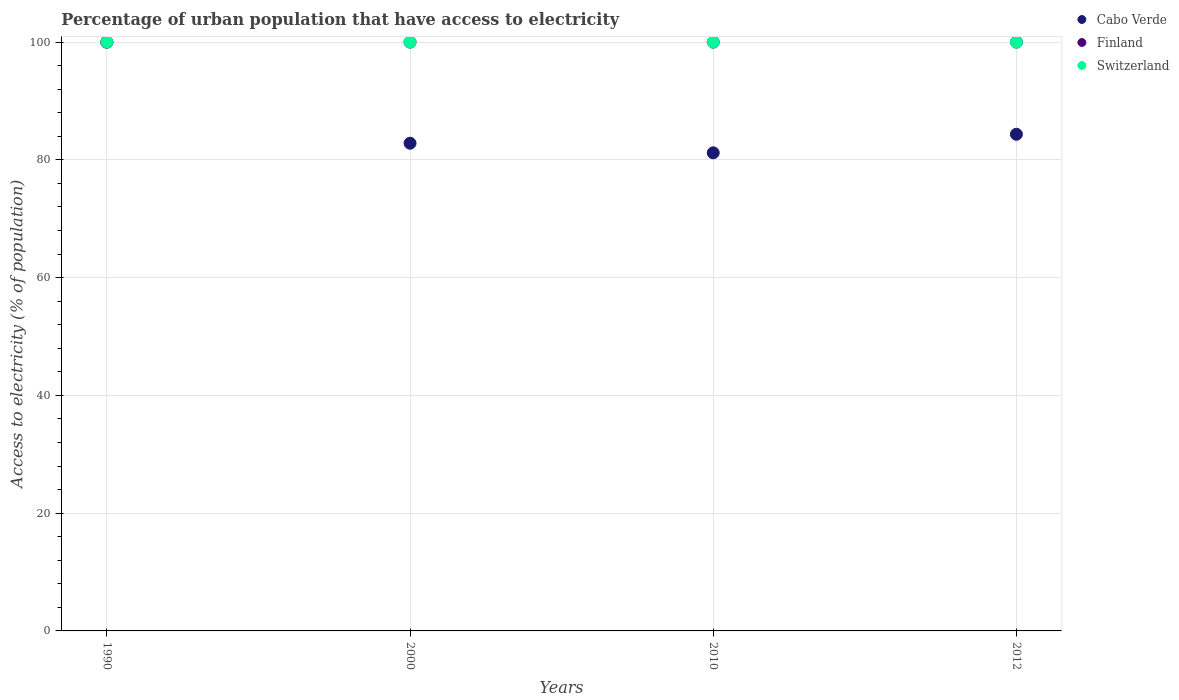Is the number of dotlines equal to the number of legend labels?
Offer a very short reply. Yes. What is the percentage of urban population that have access to electricity in Switzerland in 2012?
Provide a succinct answer. 100. Across all years, what is the maximum percentage of urban population that have access to electricity in Switzerland?
Provide a short and direct response. 100. Across all years, what is the minimum percentage of urban population that have access to electricity in Switzerland?
Your response must be concise. 100. In which year was the percentage of urban population that have access to electricity in Cabo Verde maximum?
Your answer should be compact. 1990. What is the total percentage of urban population that have access to electricity in Cabo Verde in the graph?
Give a very brief answer. 348.37. What is the difference between the percentage of urban population that have access to electricity in Cabo Verde in 2000 and that in 2012?
Make the answer very short. -1.53. What is the difference between the percentage of urban population that have access to electricity in Cabo Verde in 1990 and the percentage of urban population that have access to electricity in Finland in 2012?
Offer a very short reply. 0. In the year 2000, what is the difference between the percentage of urban population that have access to electricity in Switzerland and percentage of urban population that have access to electricity in Cabo Verde?
Your response must be concise. 17.17. In how many years, is the percentage of urban population that have access to electricity in Cabo Verde greater than 4 %?
Your answer should be very brief. 4. What is the difference between the highest and the lowest percentage of urban population that have access to electricity in Cabo Verde?
Your answer should be very brief. 18.8. In how many years, is the percentage of urban population that have access to electricity in Cabo Verde greater than the average percentage of urban population that have access to electricity in Cabo Verde taken over all years?
Your response must be concise. 1. Is the sum of the percentage of urban population that have access to electricity in Cabo Verde in 2000 and 2010 greater than the maximum percentage of urban population that have access to electricity in Switzerland across all years?
Your response must be concise. Yes. Is it the case that in every year, the sum of the percentage of urban population that have access to electricity in Finland and percentage of urban population that have access to electricity in Cabo Verde  is greater than the percentage of urban population that have access to electricity in Switzerland?
Provide a succinct answer. Yes. Does the percentage of urban population that have access to electricity in Finland monotonically increase over the years?
Your answer should be compact. No. Is the percentage of urban population that have access to electricity in Finland strictly less than the percentage of urban population that have access to electricity in Cabo Verde over the years?
Your answer should be very brief. No. How many dotlines are there?
Your answer should be very brief. 3. How many years are there in the graph?
Your answer should be very brief. 4. What is the difference between two consecutive major ticks on the Y-axis?
Make the answer very short. 20. Are the values on the major ticks of Y-axis written in scientific E-notation?
Your answer should be compact. No. Does the graph contain grids?
Your response must be concise. Yes. How many legend labels are there?
Ensure brevity in your answer.  3. How are the legend labels stacked?
Provide a short and direct response. Vertical. What is the title of the graph?
Provide a short and direct response. Percentage of urban population that have access to electricity. Does "Bahamas" appear as one of the legend labels in the graph?
Give a very brief answer. No. What is the label or title of the X-axis?
Ensure brevity in your answer.  Years. What is the label or title of the Y-axis?
Your answer should be compact. Access to electricity (% of population). What is the Access to electricity (% of population) of Cabo Verde in 1990?
Provide a succinct answer. 100. What is the Access to electricity (% of population) of Switzerland in 1990?
Offer a terse response. 100. What is the Access to electricity (% of population) in Cabo Verde in 2000?
Provide a succinct answer. 82.83. What is the Access to electricity (% of population) of Cabo Verde in 2010?
Your answer should be very brief. 81.2. What is the Access to electricity (% of population) of Cabo Verde in 2012?
Keep it short and to the point. 84.35. Across all years, what is the maximum Access to electricity (% of population) in Finland?
Provide a succinct answer. 100. Across all years, what is the maximum Access to electricity (% of population) of Switzerland?
Provide a succinct answer. 100. Across all years, what is the minimum Access to electricity (% of population) of Cabo Verde?
Keep it short and to the point. 81.2. Across all years, what is the minimum Access to electricity (% of population) of Switzerland?
Provide a short and direct response. 100. What is the total Access to electricity (% of population) in Cabo Verde in the graph?
Your answer should be compact. 348.37. What is the total Access to electricity (% of population) in Switzerland in the graph?
Provide a succinct answer. 400. What is the difference between the Access to electricity (% of population) in Cabo Verde in 1990 and that in 2000?
Make the answer very short. 17.17. What is the difference between the Access to electricity (% of population) in Finland in 1990 and that in 2000?
Offer a terse response. 0. What is the difference between the Access to electricity (% of population) in Switzerland in 1990 and that in 2000?
Offer a terse response. 0. What is the difference between the Access to electricity (% of population) of Cabo Verde in 1990 and that in 2010?
Ensure brevity in your answer.  18.8. What is the difference between the Access to electricity (% of population) in Finland in 1990 and that in 2010?
Make the answer very short. 0. What is the difference between the Access to electricity (% of population) of Cabo Verde in 1990 and that in 2012?
Your answer should be compact. 15.65. What is the difference between the Access to electricity (% of population) in Switzerland in 1990 and that in 2012?
Provide a succinct answer. 0. What is the difference between the Access to electricity (% of population) of Cabo Verde in 2000 and that in 2010?
Offer a very short reply. 1.63. What is the difference between the Access to electricity (% of population) in Finland in 2000 and that in 2010?
Give a very brief answer. 0. What is the difference between the Access to electricity (% of population) of Switzerland in 2000 and that in 2010?
Make the answer very short. 0. What is the difference between the Access to electricity (% of population) of Cabo Verde in 2000 and that in 2012?
Give a very brief answer. -1.53. What is the difference between the Access to electricity (% of population) of Cabo Verde in 2010 and that in 2012?
Offer a terse response. -3.15. What is the difference between the Access to electricity (% of population) of Finland in 2010 and that in 2012?
Your answer should be very brief. 0. What is the difference between the Access to electricity (% of population) of Cabo Verde in 1990 and the Access to electricity (% of population) of Switzerland in 2000?
Your response must be concise. 0. What is the difference between the Access to electricity (% of population) in Finland in 1990 and the Access to electricity (% of population) in Switzerland in 2000?
Your answer should be very brief. 0. What is the difference between the Access to electricity (% of population) of Cabo Verde in 1990 and the Access to electricity (% of population) of Finland in 2010?
Provide a succinct answer. 0. What is the difference between the Access to electricity (% of population) in Cabo Verde in 1990 and the Access to electricity (% of population) in Switzerland in 2010?
Offer a very short reply. 0. What is the difference between the Access to electricity (% of population) of Cabo Verde in 1990 and the Access to electricity (% of population) of Finland in 2012?
Your response must be concise. 0. What is the difference between the Access to electricity (% of population) of Finland in 1990 and the Access to electricity (% of population) of Switzerland in 2012?
Your answer should be compact. 0. What is the difference between the Access to electricity (% of population) of Cabo Verde in 2000 and the Access to electricity (% of population) of Finland in 2010?
Your answer should be very brief. -17.17. What is the difference between the Access to electricity (% of population) in Cabo Verde in 2000 and the Access to electricity (% of population) in Switzerland in 2010?
Provide a short and direct response. -17.17. What is the difference between the Access to electricity (% of population) of Finland in 2000 and the Access to electricity (% of population) of Switzerland in 2010?
Make the answer very short. 0. What is the difference between the Access to electricity (% of population) in Cabo Verde in 2000 and the Access to electricity (% of population) in Finland in 2012?
Give a very brief answer. -17.17. What is the difference between the Access to electricity (% of population) in Cabo Verde in 2000 and the Access to electricity (% of population) in Switzerland in 2012?
Provide a short and direct response. -17.17. What is the difference between the Access to electricity (% of population) in Finland in 2000 and the Access to electricity (% of population) in Switzerland in 2012?
Offer a terse response. 0. What is the difference between the Access to electricity (% of population) in Cabo Verde in 2010 and the Access to electricity (% of population) in Finland in 2012?
Keep it short and to the point. -18.8. What is the difference between the Access to electricity (% of population) of Cabo Verde in 2010 and the Access to electricity (% of population) of Switzerland in 2012?
Your answer should be very brief. -18.8. What is the average Access to electricity (% of population) in Cabo Verde per year?
Give a very brief answer. 87.09. What is the average Access to electricity (% of population) in Switzerland per year?
Provide a succinct answer. 100. In the year 1990, what is the difference between the Access to electricity (% of population) in Cabo Verde and Access to electricity (% of population) in Finland?
Keep it short and to the point. 0. In the year 1990, what is the difference between the Access to electricity (% of population) of Cabo Verde and Access to electricity (% of population) of Switzerland?
Provide a short and direct response. 0. In the year 2000, what is the difference between the Access to electricity (% of population) in Cabo Verde and Access to electricity (% of population) in Finland?
Give a very brief answer. -17.17. In the year 2000, what is the difference between the Access to electricity (% of population) in Cabo Verde and Access to electricity (% of population) in Switzerland?
Offer a very short reply. -17.17. In the year 2000, what is the difference between the Access to electricity (% of population) in Finland and Access to electricity (% of population) in Switzerland?
Make the answer very short. 0. In the year 2010, what is the difference between the Access to electricity (% of population) in Cabo Verde and Access to electricity (% of population) in Finland?
Offer a very short reply. -18.8. In the year 2010, what is the difference between the Access to electricity (% of population) in Cabo Verde and Access to electricity (% of population) in Switzerland?
Offer a terse response. -18.8. In the year 2012, what is the difference between the Access to electricity (% of population) of Cabo Verde and Access to electricity (% of population) of Finland?
Give a very brief answer. -15.65. In the year 2012, what is the difference between the Access to electricity (% of population) in Cabo Verde and Access to electricity (% of population) in Switzerland?
Provide a succinct answer. -15.65. What is the ratio of the Access to electricity (% of population) of Cabo Verde in 1990 to that in 2000?
Provide a short and direct response. 1.21. What is the ratio of the Access to electricity (% of population) in Finland in 1990 to that in 2000?
Ensure brevity in your answer.  1. What is the ratio of the Access to electricity (% of population) in Cabo Verde in 1990 to that in 2010?
Keep it short and to the point. 1.23. What is the ratio of the Access to electricity (% of population) of Cabo Verde in 1990 to that in 2012?
Offer a terse response. 1.19. What is the ratio of the Access to electricity (% of population) of Switzerland in 1990 to that in 2012?
Keep it short and to the point. 1. What is the ratio of the Access to electricity (% of population) of Cabo Verde in 2000 to that in 2010?
Your answer should be compact. 1.02. What is the ratio of the Access to electricity (% of population) of Finland in 2000 to that in 2010?
Keep it short and to the point. 1. What is the ratio of the Access to electricity (% of population) in Cabo Verde in 2000 to that in 2012?
Give a very brief answer. 0.98. What is the ratio of the Access to electricity (% of population) of Finland in 2000 to that in 2012?
Your response must be concise. 1. What is the ratio of the Access to electricity (% of population) in Switzerland in 2000 to that in 2012?
Your answer should be very brief. 1. What is the ratio of the Access to electricity (% of population) in Cabo Verde in 2010 to that in 2012?
Ensure brevity in your answer.  0.96. What is the difference between the highest and the second highest Access to electricity (% of population) in Cabo Verde?
Your answer should be very brief. 15.65. What is the difference between the highest and the lowest Access to electricity (% of population) in Cabo Verde?
Your answer should be very brief. 18.8. What is the difference between the highest and the lowest Access to electricity (% of population) of Finland?
Your response must be concise. 0. 